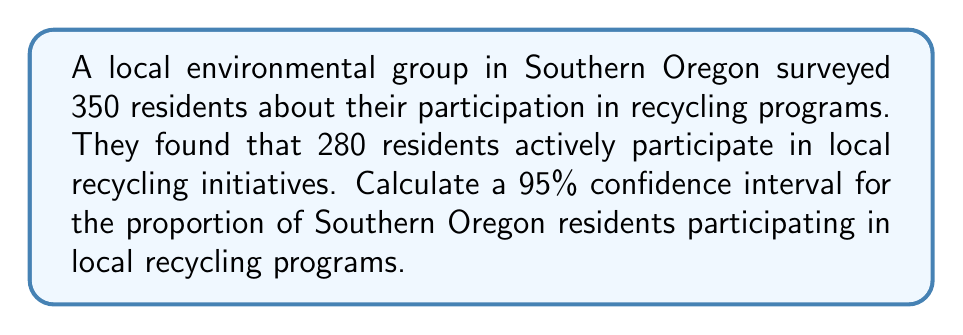Teach me how to tackle this problem. Let's approach this step-by-step:

1) First, we need to calculate the sample proportion:
   $\hat{p} = \frac{\text{number of successes}}{\text{sample size}} = \frac{280}{350} = 0.8$

2) The formula for the confidence interval is:
   $$\hat{p} \pm z_{\alpha/2} \sqrt{\frac{\hat{p}(1-\hat{p})}{n}}$$
   where $z_{\alpha/2}$ is the critical value for the desired confidence level.

3) For a 95% confidence interval, $z_{\alpha/2} = 1.96$

4) Now, let's substitute our values:
   $n = 350$
   $\hat{p} = 0.8$

5) Calculate the standard error:
   $$SE = \sqrt{\frac{\hat{p}(1-\hat{p})}{n}} = \sqrt{\frac{0.8(1-0.8)}{350}} = \sqrt{\frac{0.16}{350}} \approx 0.0214$$

6) Now we can calculate the margin of error:
   $$ME = 1.96 \times 0.0214 \approx 0.0419$$

7) Finally, we can construct our confidence interval:
   $$0.8 \pm 0.0419$$
   
   Lower bound: $0.8 - 0.0419 = 0.7581$
   Upper bound: $0.8 + 0.0419 = 0.8419$

Therefore, we are 95% confident that the true proportion of Southern Oregon residents participating in local recycling programs is between 0.7581 and 0.8419, or approximately 75.81% to 84.19%.
Answer: (0.7581, 0.8419) 